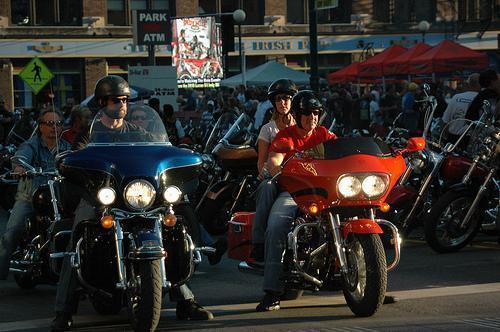How many people are wearing helmets?
Give a very brief answer. 3. How many headlights on the red bike?
Give a very brief answer. 2. How many headlights are on?
Give a very brief answer. 5. 